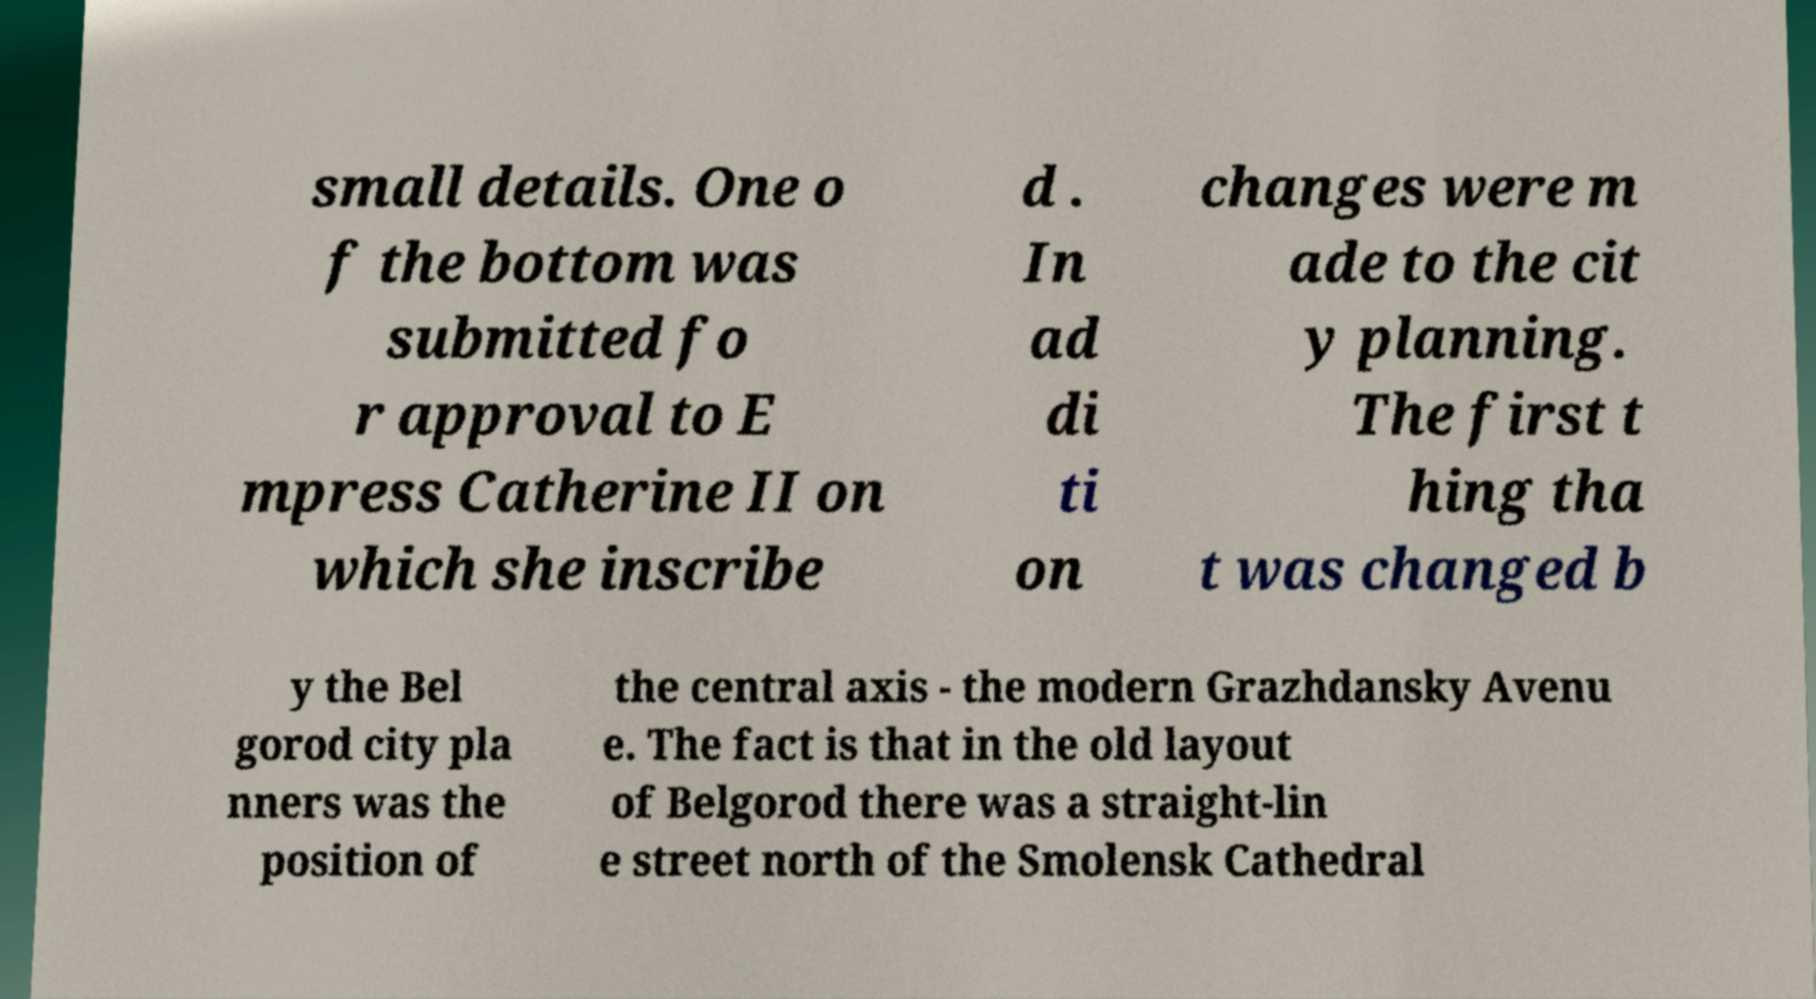I need the written content from this picture converted into text. Can you do that? small details. One o f the bottom was submitted fo r approval to E mpress Catherine II on which she inscribe d . In ad di ti on changes were m ade to the cit y planning. The first t hing tha t was changed b y the Bel gorod city pla nners was the position of the central axis - the modern Grazhdansky Avenu e. The fact is that in the old layout of Belgorod there was a straight-lin e street north of the Smolensk Cathedral 